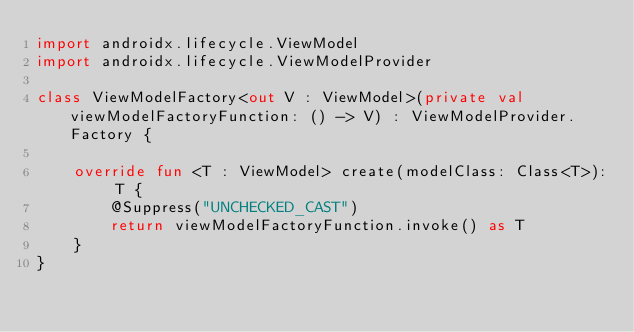<code> <loc_0><loc_0><loc_500><loc_500><_Kotlin_>import androidx.lifecycle.ViewModel
import androidx.lifecycle.ViewModelProvider

class ViewModelFactory<out V : ViewModel>(private val viewModelFactoryFunction: () -> V) : ViewModelProvider.Factory {

    override fun <T : ViewModel> create(modelClass: Class<T>): T {
        @Suppress("UNCHECKED_CAST")
        return viewModelFactoryFunction.invoke() as T
    }
}
</code> 